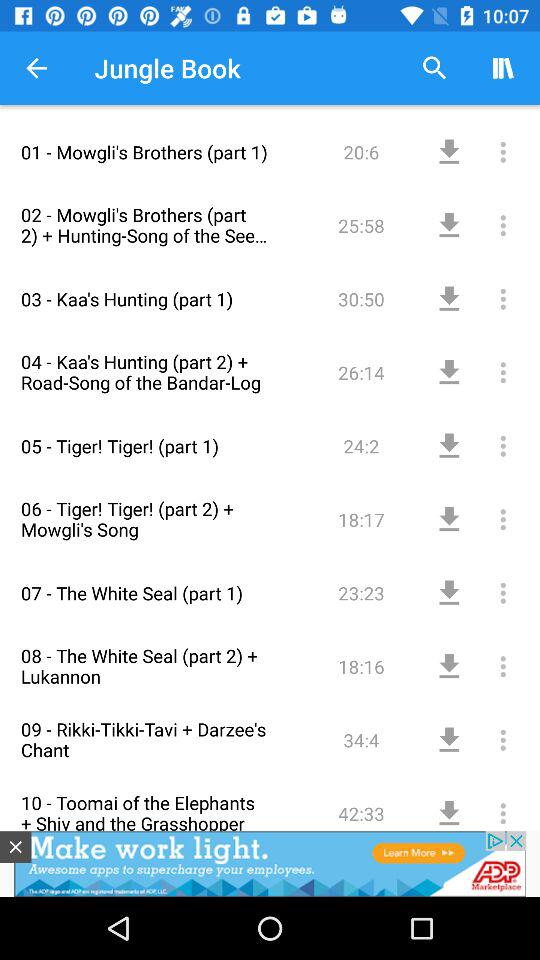How many episodes are there in total?
Answer the question using a single word or phrase. 10 